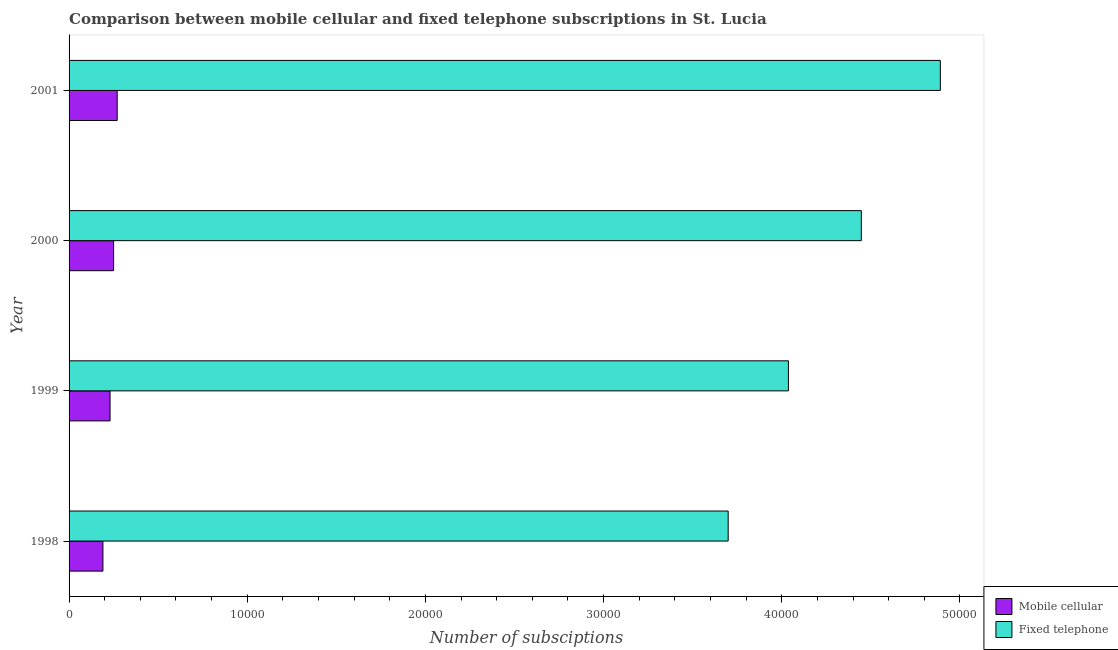How many bars are there on the 3rd tick from the top?
Your answer should be compact. 2. How many bars are there on the 2nd tick from the bottom?
Offer a terse response. 2. What is the label of the 4th group of bars from the top?
Offer a very short reply. 1998. What is the number of mobile cellular subscriptions in 2000?
Provide a succinct answer. 2500. Across all years, what is the maximum number of mobile cellular subscriptions?
Ensure brevity in your answer.  2700. Across all years, what is the minimum number of fixed telephone subscriptions?
Offer a terse response. 3.70e+04. What is the total number of mobile cellular subscriptions in the graph?
Offer a very short reply. 9400. What is the difference between the number of mobile cellular subscriptions in 1998 and that in 2000?
Offer a terse response. -600. What is the difference between the number of fixed telephone subscriptions in 1999 and the number of mobile cellular subscriptions in 1998?
Provide a short and direct response. 3.85e+04. What is the average number of fixed telephone subscriptions per year?
Offer a terse response. 4.27e+04. In the year 2000, what is the difference between the number of mobile cellular subscriptions and number of fixed telephone subscriptions?
Your response must be concise. -4.20e+04. In how many years, is the number of fixed telephone subscriptions greater than 44000 ?
Ensure brevity in your answer.  2. What is the ratio of the number of mobile cellular subscriptions in 1998 to that in 2000?
Your answer should be very brief. 0.76. Is the number of mobile cellular subscriptions in 1999 less than that in 2001?
Offer a terse response. Yes. Is the difference between the number of mobile cellular subscriptions in 2000 and 2001 greater than the difference between the number of fixed telephone subscriptions in 2000 and 2001?
Ensure brevity in your answer.  Yes. What is the difference between the highest and the second highest number of fixed telephone subscriptions?
Provide a succinct answer. 4435. What is the difference between the highest and the lowest number of mobile cellular subscriptions?
Your answer should be very brief. 800. What does the 2nd bar from the top in 1999 represents?
Your response must be concise. Mobile cellular. What does the 1st bar from the bottom in 1999 represents?
Provide a succinct answer. Mobile cellular. How many bars are there?
Ensure brevity in your answer.  8. How many years are there in the graph?
Give a very brief answer. 4. Where does the legend appear in the graph?
Keep it short and to the point. Bottom right. What is the title of the graph?
Give a very brief answer. Comparison between mobile cellular and fixed telephone subscriptions in St. Lucia. What is the label or title of the X-axis?
Your answer should be compact. Number of subsciptions. What is the label or title of the Y-axis?
Keep it short and to the point. Year. What is the Number of subsciptions of Mobile cellular in 1998?
Your answer should be compact. 1900. What is the Number of subsciptions of Fixed telephone in 1998?
Make the answer very short. 3.70e+04. What is the Number of subsciptions of Mobile cellular in 1999?
Provide a short and direct response. 2300. What is the Number of subsciptions in Fixed telephone in 1999?
Offer a terse response. 4.04e+04. What is the Number of subsciptions in Mobile cellular in 2000?
Your response must be concise. 2500. What is the Number of subsciptions in Fixed telephone in 2000?
Your response must be concise. 4.45e+04. What is the Number of subsciptions in Mobile cellular in 2001?
Offer a terse response. 2700. What is the Number of subsciptions in Fixed telephone in 2001?
Make the answer very short. 4.89e+04. Across all years, what is the maximum Number of subsciptions in Mobile cellular?
Make the answer very short. 2700. Across all years, what is the maximum Number of subsciptions in Fixed telephone?
Ensure brevity in your answer.  4.89e+04. Across all years, what is the minimum Number of subsciptions of Mobile cellular?
Your answer should be very brief. 1900. Across all years, what is the minimum Number of subsciptions in Fixed telephone?
Offer a terse response. 3.70e+04. What is the total Number of subsciptions of Mobile cellular in the graph?
Offer a terse response. 9400. What is the total Number of subsciptions of Fixed telephone in the graph?
Make the answer very short. 1.71e+05. What is the difference between the Number of subsciptions in Mobile cellular in 1998 and that in 1999?
Your answer should be very brief. -400. What is the difference between the Number of subsciptions of Fixed telephone in 1998 and that in 1999?
Your response must be concise. -3381. What is the difference between the Number of subsciptions in Mobile cellular in 1998 and that in 2000?
Your answer should be very brief. -600. What is the difference between the Number of subsciptions of Fixed telephone in 1998 and that in 2000?
Offer a very short reply. -7473. What is the difference between the Number of subsciptions of Mobile cellular in 1998 and that in 2001?
Provide a short and direct response. -800. What is the difference between the Number of subsciptions of Fixed telephone in 1998 and that in 2001?
Give a very brief answer. -1.19e+04. What is the difference between the Number of subsciptions of Mobile cellular in 1999 and that in 2000?
Ensure brevity in your answer.  -200. What is the difference between the Number of subsciptions of Fixed telephone in 1999 and that in 2000?
Offer a very short reply. -4092. What is the difference between the Number of subsciptions of Mobile cellular in 1999 and that in 2001?
Your answer should be very brief. -400. What is the difference between the Number of subsciptions of Fixed telephone in 1999 and that in 2001?
Give a very brief answer. -8527. What is the difference between the Number of subsciptions of Mobile cellular in 2000 and that in 2001?
Your answer should be compact. -200. What is the difference between the Number of subsciptions of Fixed telephone in 2000 and that in 2001?
Make the answer very short. -4435. What is the difference between the Number of subsciptions in Mobile cellular in 1998 and the Number of subsciptions in Fixed telephone in 1999?
Give a very brief answer. -3.85e+04. What is the difference between the Number of subsciptions in Mobile cellular in 1998 and the Number of subsciptions in Fixed telephone in 2000?
Offer a terse response. -4.26e+04. What is the difference between the Number of subsciptions of Mobile cellular in 1998 and the Number of subsciptions of Fixed telephone in 2001?
Your answer should be very brief. -4.70e+04. What is the difference between the Number of subsciptions in Mobile cellular in 1999 and the Number of subsciptions in Fixed telephone in 2000?
Offer a very short reply. -4.22e+04. What is the difference between the Number of subsciptions of Mobile cellular in 1999 and the Number of subsciptions of Fixed telephone in 2001?
Make the answer very short. -4.66e+04. What is the difference between the Number of subsciptions of Mobile cellular in 2000 and the Number of subsciptions of Fixed telephone in 2001?
Offer a terse response. -4.64e+04. What is the average Number of subsciptions in Mobile cellular per year?
Offer a very short reply. 2350. What is the average Number of subsciptions of Fixed telephone per year?
Provide a succinct answer. 4.27e+04. In the year 1998, what is the difference between the Number of subsciptions in Mobile cellular and Number of subsciptions in Fixed telephone?
Offer a terse response. -3.51e+04. In the year 1999, what is the difference between the Number of subsciptions of Mobile cellular and Number of subsciptions of Fixed telephone?
Your answer should be compact. -3.81e+04. In the year 2000, what is the difference between the Number of subsciptions of Mobile cellular and Number of subsciptions of Fixed telephone?
Provide a short and direct response. -4.20e+04. In the year 2001, what is the difference between the Number of subsciptions in Mobile cellular and Number of subsciptions in Fixed telephone?
Provide a short and direct response. -4.62e+04. What is the ratio of the Number of subsciptions of Mobile cellular in 1998 to that in 1999?
Make the answer very short. 0.83. What is the ratio of the Number of subsciptions of Fixed telephone in 1998 to that in 1999?
Provide a short and direct response. 0.92. What is the ratio of the Number of subsciptions in Mobile cellular in 1998 to that in 2000?
Keep it short and to the point. 0.76. What is the ratio of the Number of subsciptions of Fixed telephone in 1998 to that in 2000?
Make the answer very short. 0.83. What is the ratio of the Number of subsciptions in Mobile cellular in 1998 to that in 2001?
Give a very brief answer. 0.7. What is the ratio of the Number of subsciptions of Fixed telephone in 1998 to that in 2001?
Offer a very short reply. 0.76. What is the ratio of the Number of subsciptions of Fixed telephone in 1999 to that in 2000?
Give a very brief answer. 0.91. What is the ratio of the Number of subsciptions of Mobile cellular in 1999 to that in 2001?
Your answer should be compact. 0.85. What is the ratio of the Number of subsciptions of Fixed telephone in 1999 to that in 2001?
Provide a succinct answer. 0.83. What is the ratio of the Number of subsciptions of Mobile cellular in 2000 to that in 2001?
Keep it short and to the point. 0.93. What is the ratio of the Number of subsciptions in Fixed telephone in 2000 to that in 2001?
Your response must be concise. 0.91. What is the difference between the highest and the second highest Number of subsciptions in Mobile cellular?
Give a very brief answer. 200. What is the difference between the highest and the second highest Number of subsciptions of Fixed telephone?
Your answer should be compact. 4435. What is the difference between the highest and the lowest Number of subsciptions in Mobile cellular?
Provide a succinct answer. 800. What is the difference between the highest and the lowest Number of subsciptions of Fixed telephone?
Your response must be concise. 1.19e+04. 